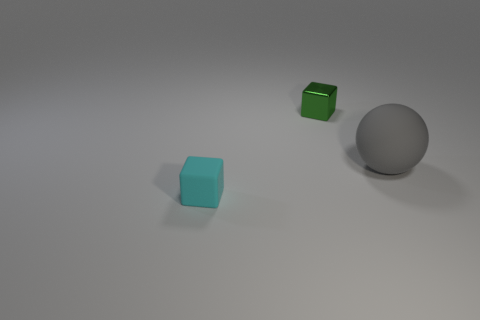Add 3 big brown shiny things. How many objects exist? 6 Subtract all blocks. How many objects are left? 1 Subtract 1 gray spheres. How many objects are left? 2 Subtract all large green metal cylinders. Subtract all small green metal objects. How many objects are left? 2 Add 2 green shiny objects. How many green shiny objects are left? 3 Add 1 green shiny things. How many green shiny things exist? 2 